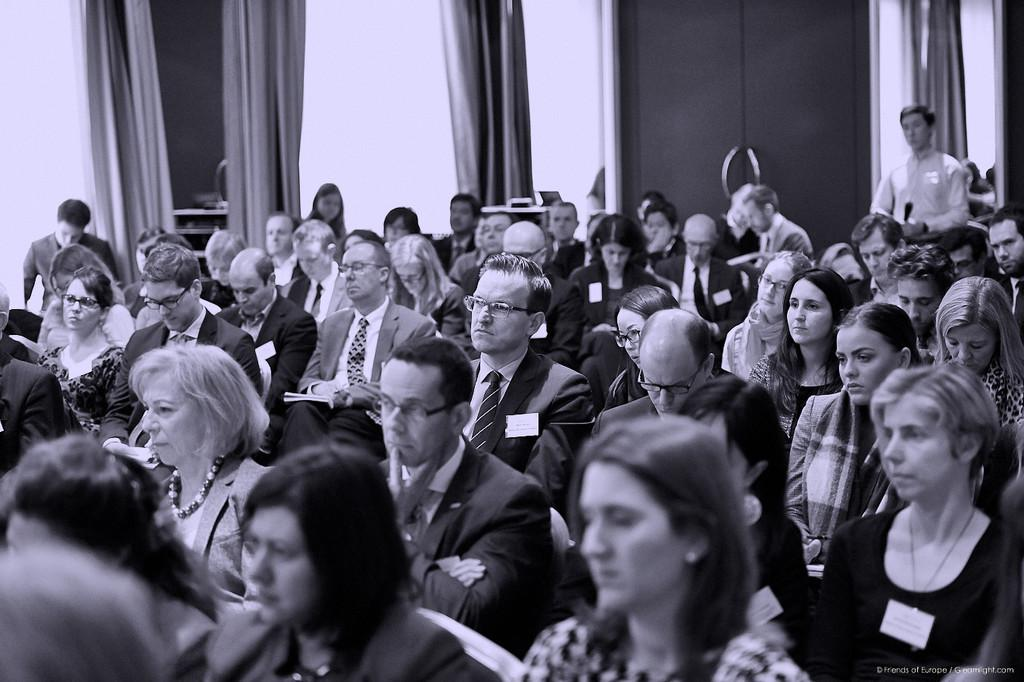What are the people in the image doing? The people in the image are sitting. Is there anyone standing in the image? Yes, there is a man standing in the image. What can be seen in the background of the image? There is a wall and curtains in the background of the image. What type of brass instrument is the hen playing in the image? There is no brass instrument or hen present in the image. 